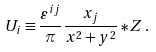Convert formula to latex. <formula><loc_0><loc_0><loc_500><loc_500>U _ { i } \equiv \frac { \varepsilon ^ { i j } } { \pi } \frac { x _ { j } } { x ^ { 2 } + y ^ { 2 } } \ast Z \, .</formula> 